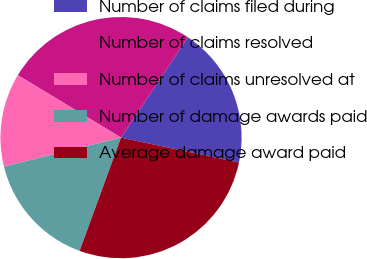<chart> <loc_0><loc_0><loc_500><loc_500><pie_chart><fcel>Number of claims filed during<fcel>Number of claims resolved<fcel>Number of claims unresolved at<fcel>Number of damage awards paid<fcel>Average damage award paid<nl><fcel>18.95%<fcel>25.7%<fcel>12.52%<fcel>15.57%<fcel>27.26%<nl></chart> 